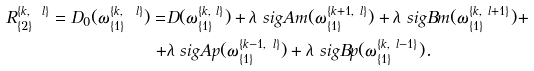<formula> <loc_0><loc_0><loc_500><loc_500>R _ { \{ 2 \} } ^ { \{ k , \ l \} } = D _ { 0 } ( \omega _ { \{ 1 \} } ^ { \{ k , \ l \} } ) = & D ( \omega _ { \{ 1 \} } ^ { \{ k , \ l \} } ) + \lambda \ s i g A m ( \omega _ { \{ 1 \} } ^ { \{ k + 1 , \ l \} } ) + \lambda \ s i g B m ( \omega _ { \{ 1 \} } ^ { \{ k , \ l + 1 \} } ) + \\ + & \lambda \ s i g A p ( \omega _ { \{ 1 \} } ^ { \{ k - 1 , \ l \} } ) + \lambda \ s i g B p ( \omega _ { \{ 1 \} } ^ { \{ k , \ l - 1 \} } ) .</formula> 